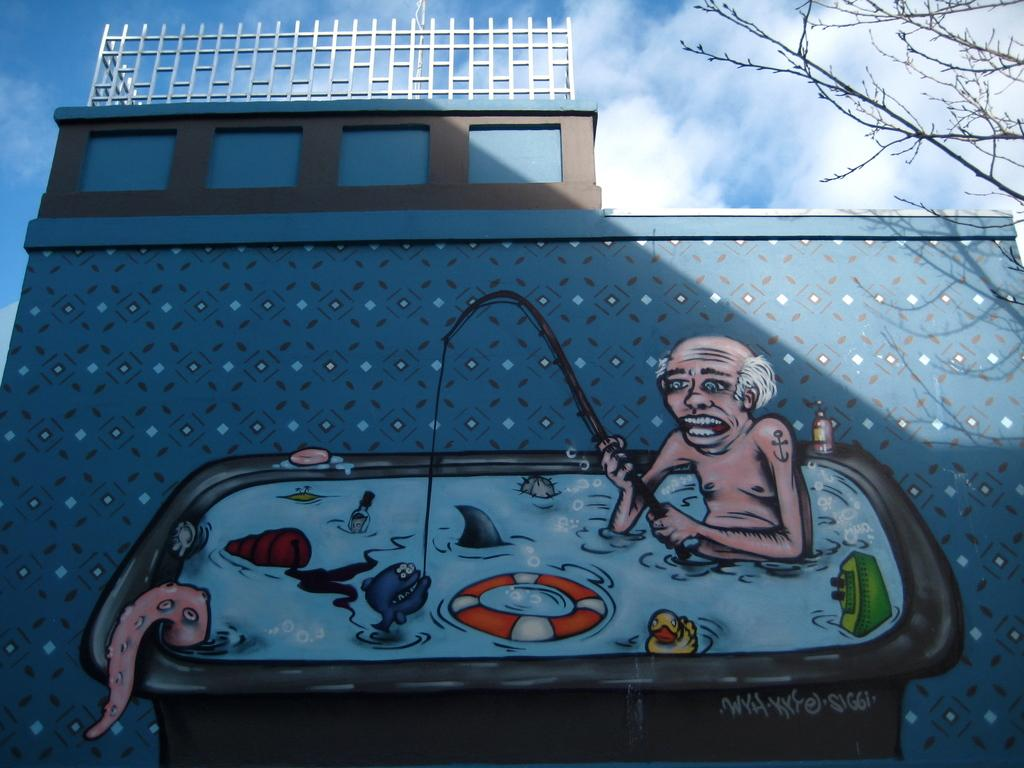What type of artwork can be seen on the building wall? There is a wall painting on the building wall. What type of structure is present in the image? There is visible in the image? What type of natural elements can be seen in the image? There are branches visible in the image. What is the current value of the slip in the image? There is no slip present in the image, so it is not possible to determine its value. 